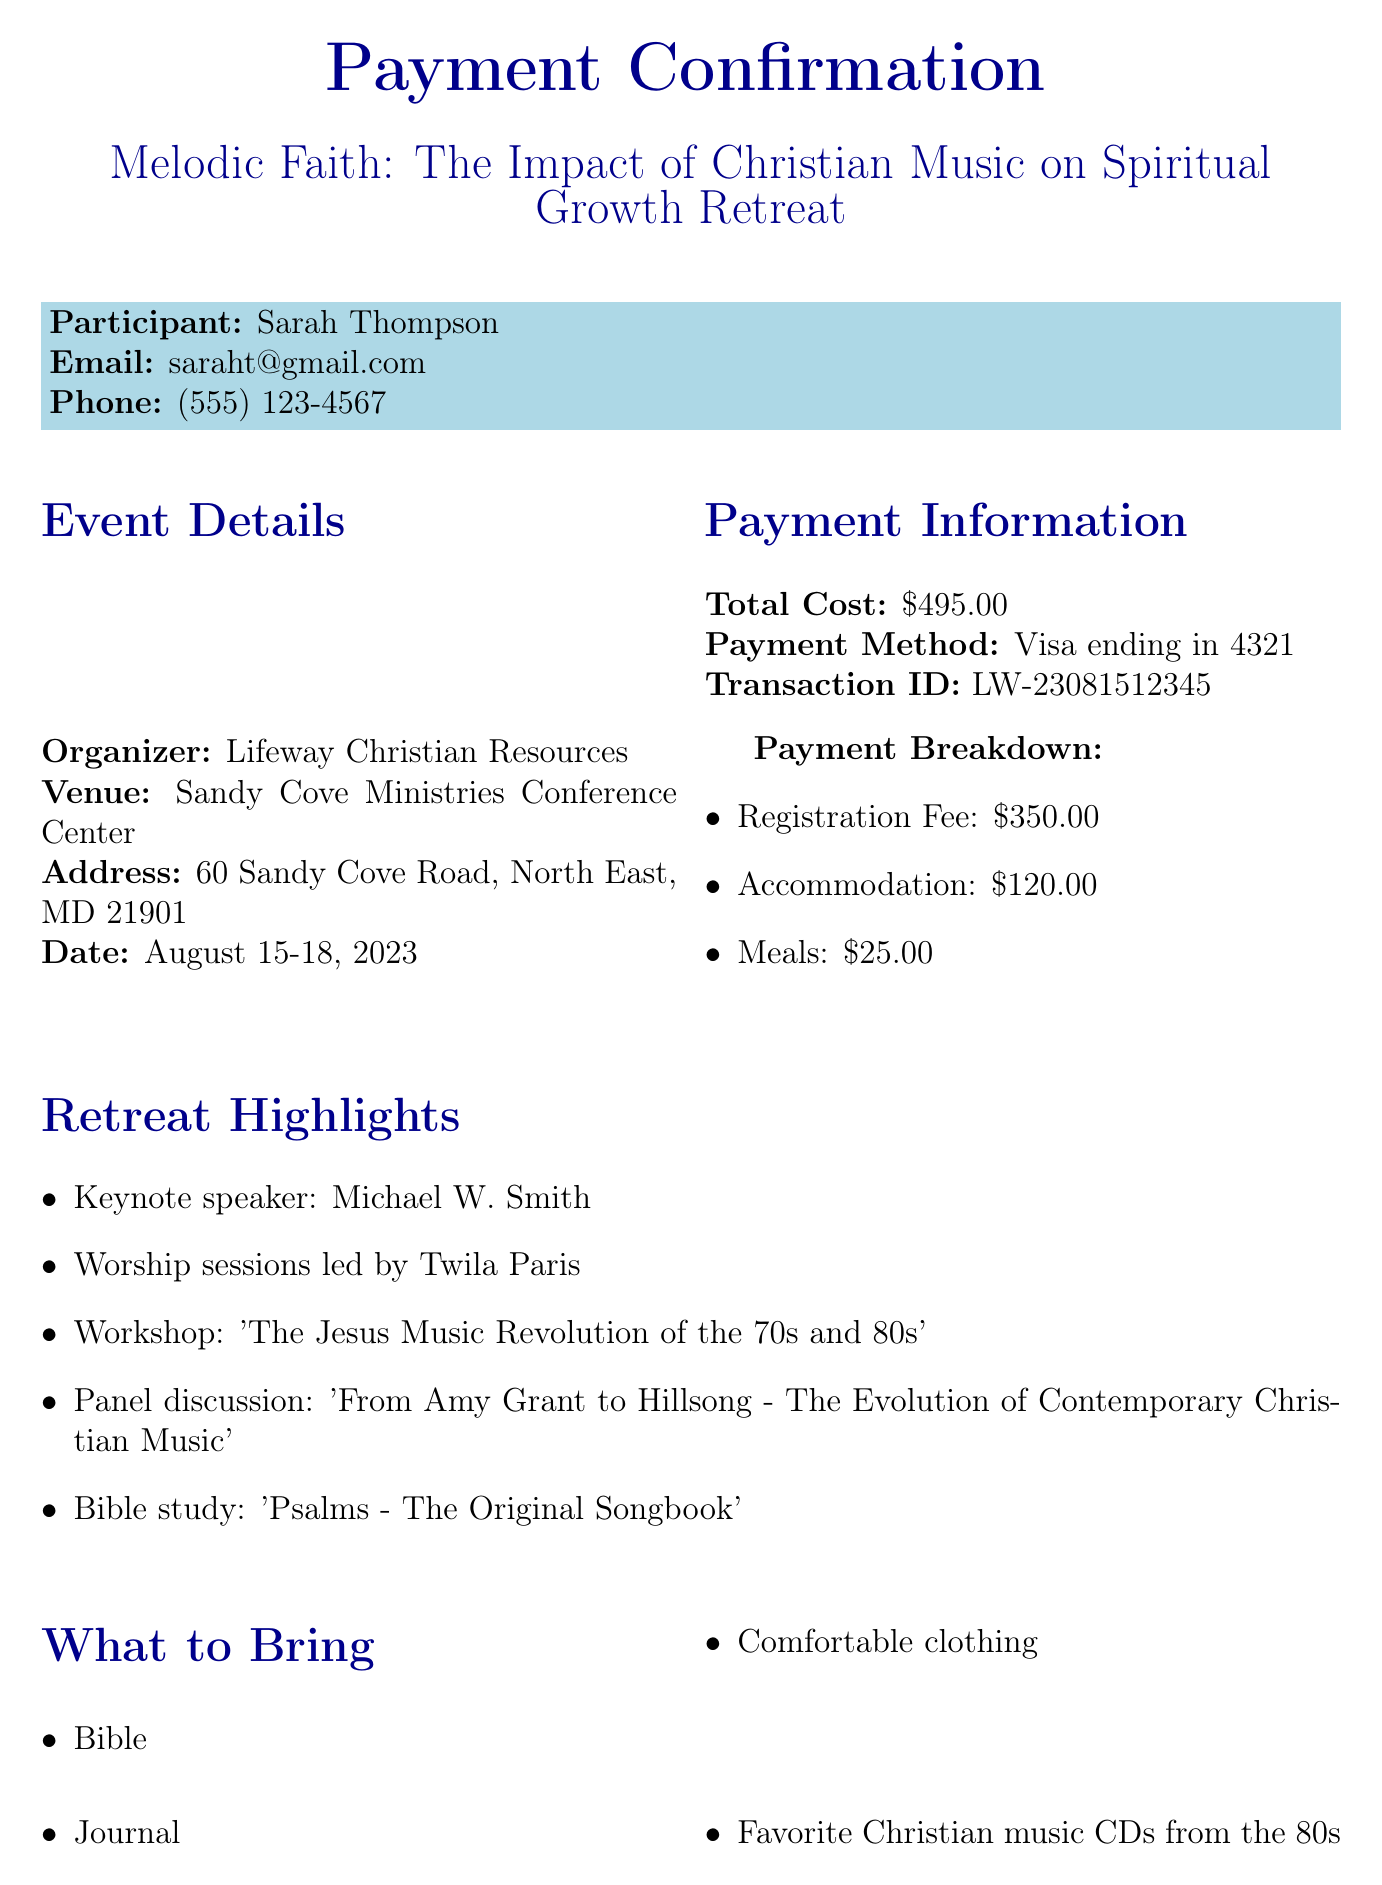What is the event name? The event name is explicitly mentioned at the top of the document as "Melodic Faith: The Impact of Christian Music on Spiritual Growth Retreat."
Answer: Melodic Faith: The Impact of Christian Music on Spiritual Growth Retreat Who is the organizer of the retreat? The document identifies the organizer as "Lifeway Christian Resources."
Answer: Lifeway Christian Resources What are the dates of the retreat? The dates for the retreat are provided in the document as "August 15-18, 2023."
Answer: August 15-18, 2023 What is the total cost for the retreat? The total cost is specified in the payment information section as "$495.00."
Answer: $495.00 How much is the registration fee? The registration fee is detailed in the payment breakdown as "$350.00."
Answer: $350.00 What special dietary requirement is noted for the participant? The document mentions that the special requirement is "Vegetarian meals."
Answer: Vegetarian meals What are participants suggested to bring? The document lists several items, including "Favorite Christian music CDs from the 80s."
Answer: Favorite Christian music CDs from the 80s What is the cancellation policy? The document outlines the cancellation policy stating, "Full refund available up to 14 days before the event."
Answer: Full refund available up to 14 days before the event Who is the keynote speaker? The document specifies the keynote speaker as "Michael W. Smith."
Answer: Michael W. Smith 